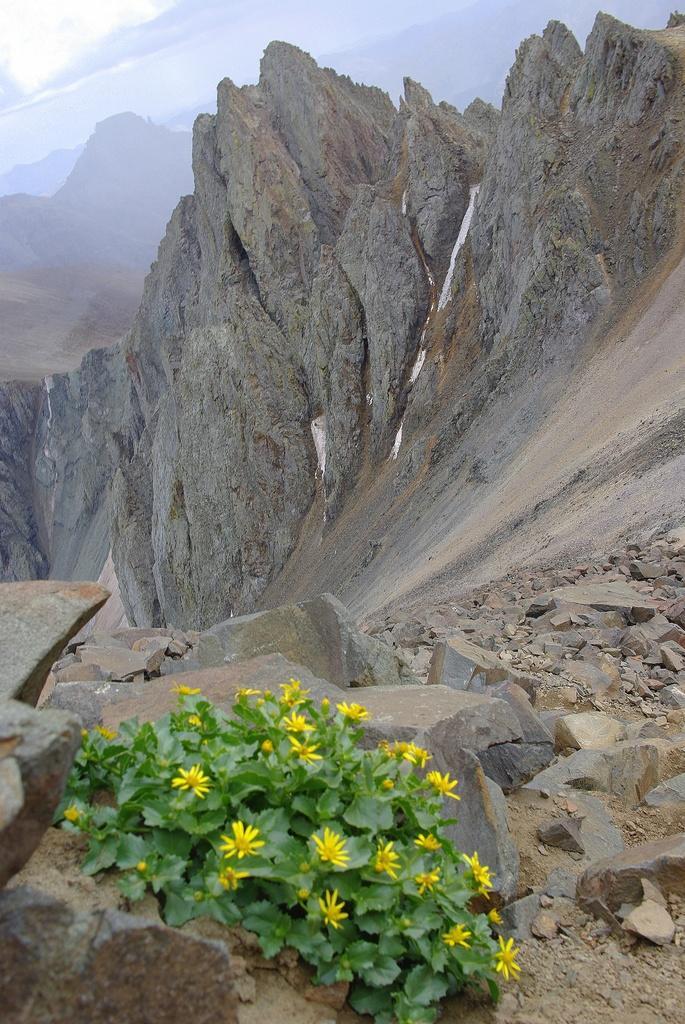In one or two sentences, can you explain what this image depicts? In this picture I can see few flowers, plants and stones at the bottom. At the top I can see the sky. 